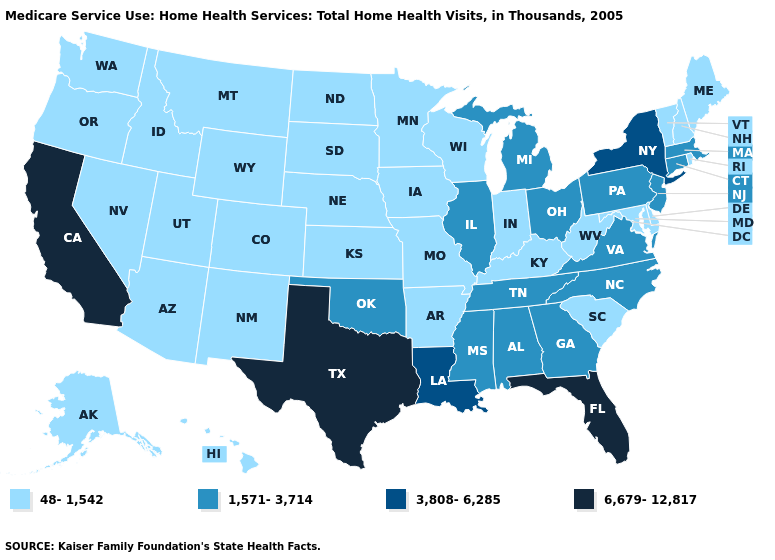Which states hav the highest value in the West?
Short answer required. California. Which states have the lowest value in the USA?
Concise answer only. Alaska, Arizona, Arkansas, Colorado, Delaware, Hawaii, Idaho, Indiana, Iowa, Kansas, Kentucky, Maine, Maryland, Minnesota, Missouri, Montana, Nebraska, Nevada, New Hampshire, New Mexico, North Dakota, Oregon, Rhode Island, South Carolina, South Dakota, Utah, Vermont, Washington, West Virginia, Wisconsin, Wyoming. Name the states that have a value in the range 6,679-12,817?
Quick response, please. California, Florida, Texas. What is the value of Mississippi?
Be succinct. 1,571-3,714. Which states hav the highest value in the Northeast?
Be succinct. New York. What is the value of Texas?
Give a very brief answer. 6,679-12,817. Name the states that have a value in the range 1,571-3,714?
Keep it brief. Alabama, Connecticut, Georgia, Illinois, Massachusetts, Michigan, Mississippi, New Jersey, North Carolina, Ohio, Oklahoma, Pennsylvania, Tennessee, Virginia. How many symbols are there in the legend?
Keep it brief. 4. Name the states that have a value in the range 48-1,542?
Be succinct. Alaska, Arizona, Arkansas, Colorado, Delaware, Hawaii, Idaho, Indiana, Iowa, Kansas, Kentucky, Maine, Maryland, Minnesota, Missouri, Montana, Nebraska, Nevada, New Hampshire, New Mexico, North Dakota, Oregon, Rhode Island, South Carolina, South Dakota, Utah, Vermont, Washington, West Virginia, Wisconsin, Wyoming. Does South Carolina have the same value as Arizona?
Concise answer only. Yes. Name the states that have a value in the range 6,679-12,817?
Write a very short answer. California, Florida, Texas. What is the lowest value in states that border New Mexico?
Quick response, please. 48-1,542. Does New York have the highest value in the Northeast?
Quick response, please. Yes. What is the value of Idaho?
Answer briefly. 48-1,542. What is the highest value in the USA?
Be succinct. 6,679-12,817. 